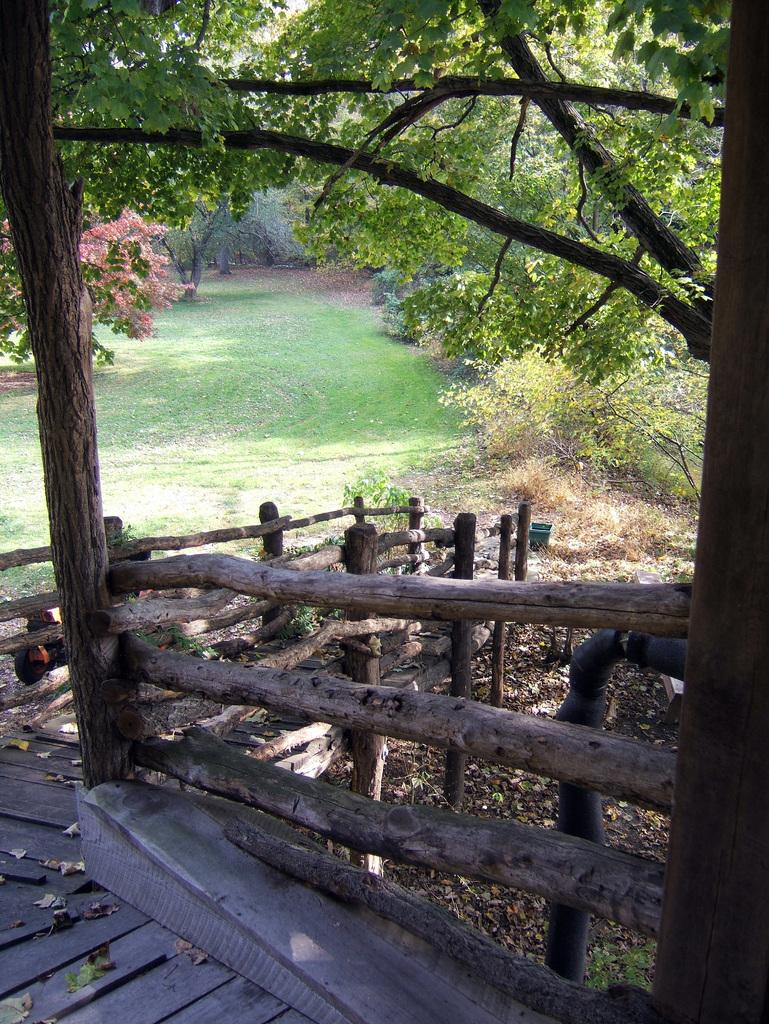What type of path is visible in the image? There is a wooden path in the image. What feature is present alongside the path? There is a railing to the side of the path. What can be seen in the background of the image? There are many trees in the background of the image. Are there any flowers visible in the image? Yes, some flowers are visible on one of the trees. What type of clam can be seen in the middle of the image? There is no clam present in the image; it features a wooden path, railing, trees, and flowers. 